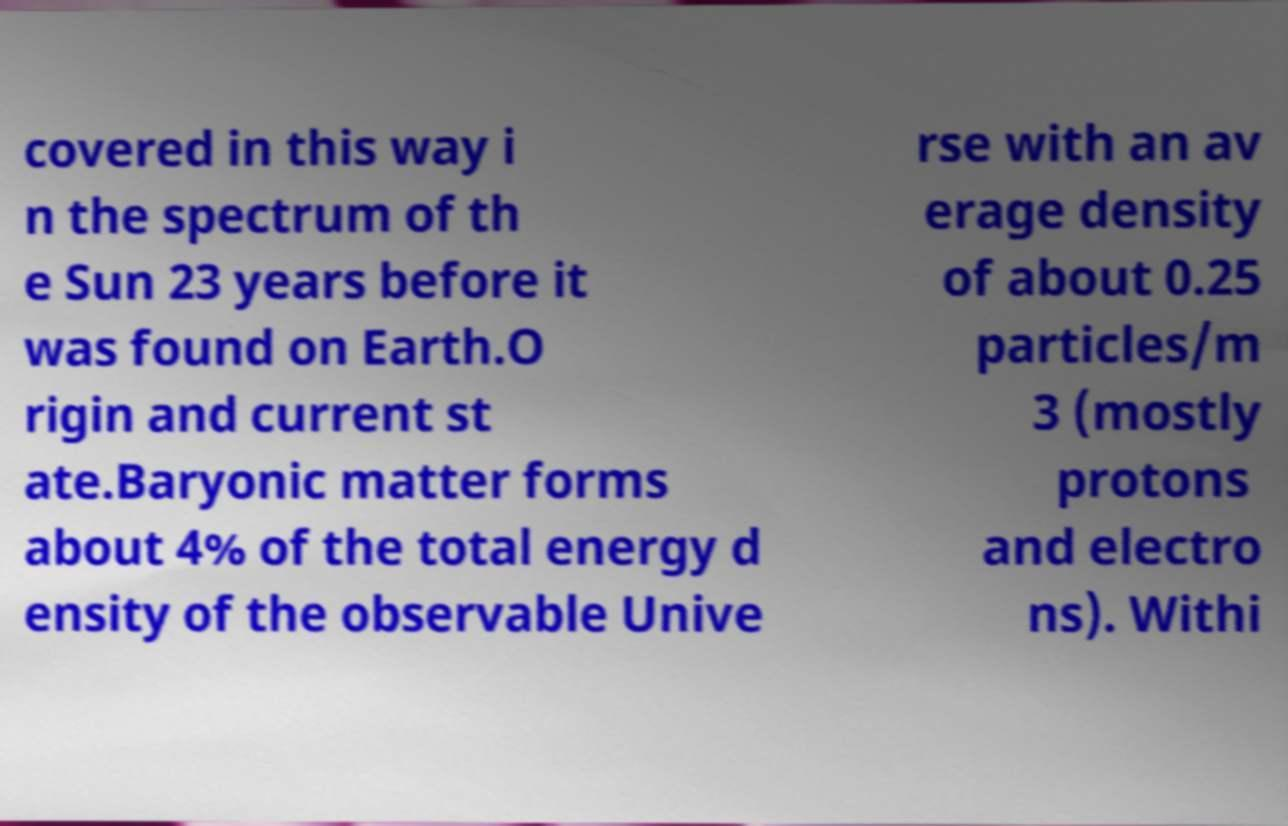I need the written content from this picture converted into text. Can you do that? covered in this way i n the spectrum of th e Sun 23 years before it was found on Earth.O rigin and current st ate.Baryonic matter forms about 4% of the total energy d ensity of the observable Unive rse with an av erage density of about 0.25 particles/m 3 (mostly protons and electro ns). Withi 